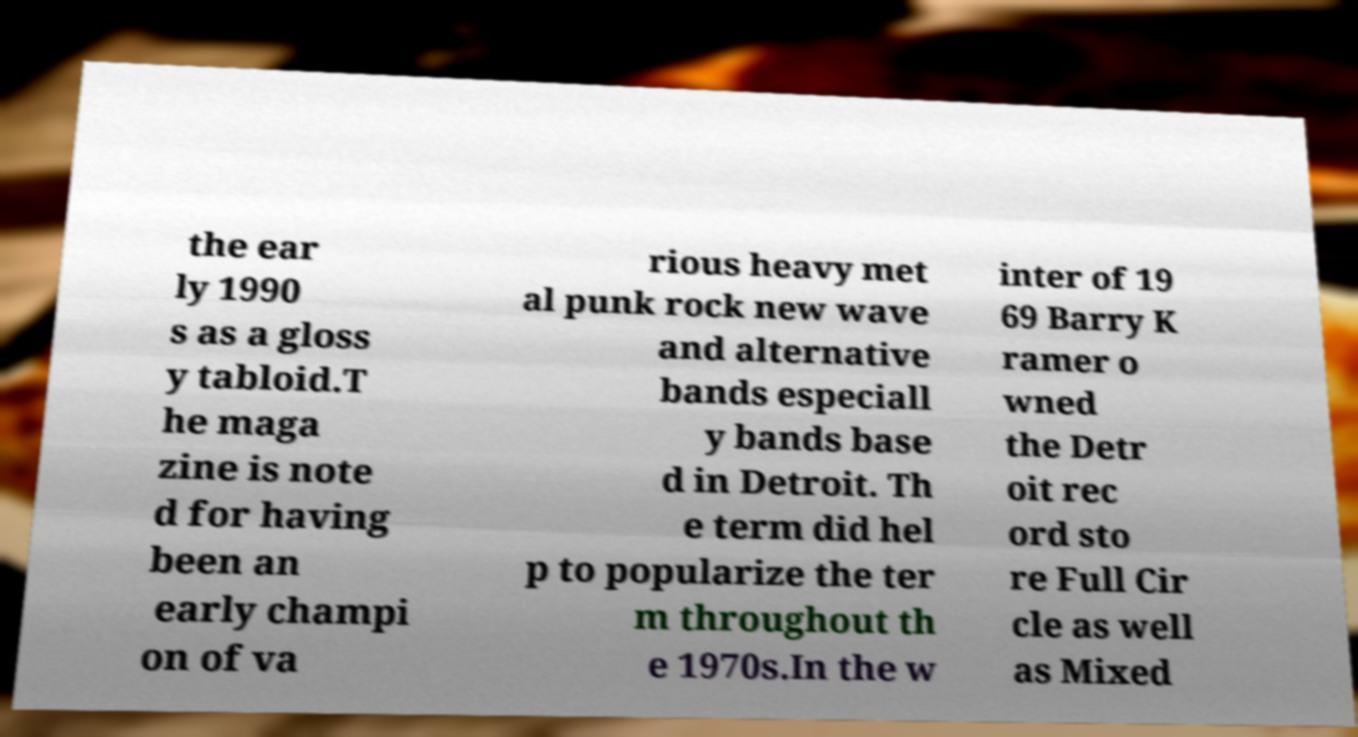Can you accurately transcribe the text from the provided image for me? the ear ly 1990 s as a gloss y tabloid.T he maga zine is note d for having been an early champi on of va rious heavy met al punk rock new wave and alternative bands especiall y bands base d in Detroit. Th e term did hel p to popularize the ter m throughout th e 1970s.In the w inter of 19 69 Barry K ramer o wned the Detr oit rec ord sto re Full Cir cle as well as Mixed 